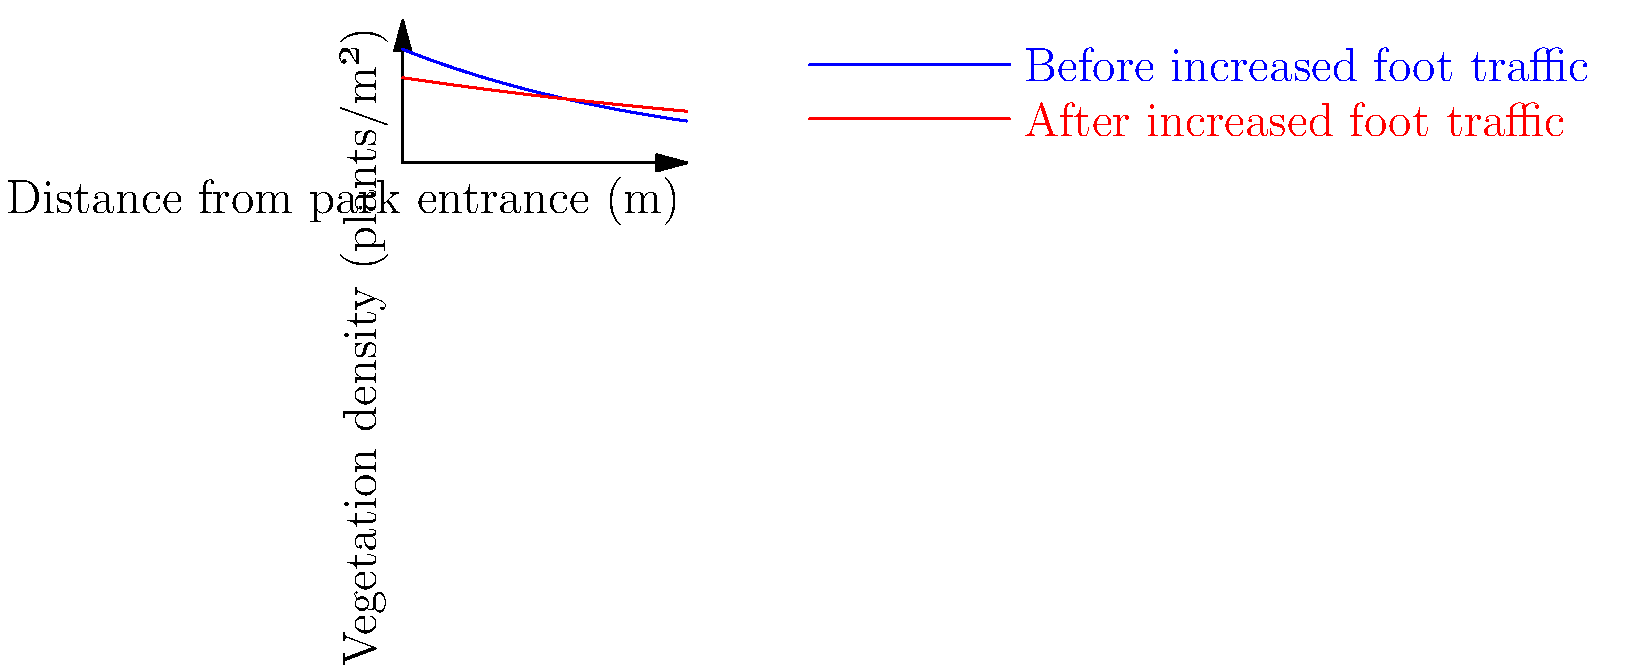The graph shows the vegetation density distribution near a wildlife park entrance before and after an increase in foot traffic. Calculate the percentage decrease in vegetation density at a distance of 50 meters from the park entrance. Round your answer to the nearest whole number. To solve this problem, we'll follow these steps:

1. Identify the equations for vegetation density:
   Before: $f_1(x) = 40e^{-0.01x}$
   After: $f_2(x) = 30e^{-0.005x}$

2. Calculate the vegetation density at 50 meters for both scenarios:
   Before: $f_1(50) = 40e^{-0.01(50)} = 40e^{-0.5} = 40 \cdot 0.6065 = 24.26$ plants/m²
   After: $f_2(50) = 30e^{-0.005(50)} = 30e^{-0.25} = 30 \cdot 0.7788 = 23.36$ plants/m²

3. Calculate the percentage decrease:
   Percentage decrease = $\frac{\text{Original} - \text{New}}{\text{Original}} \times 100\%$
   $= \frac{24.26 - 23.36}{24.26} \times 100\%$
   $= \frac{0.90}{24.26} \times 100\%$
   $= 0.0371 \times 100\%$
   $= 3.71\%$

4. Round to the nearest whole number:
   3.71% rounds to 4%

Therefore, the percentage decrease in vegetation density at 50 meters from the park entrance is approximately 4%.
Answer: 4% 